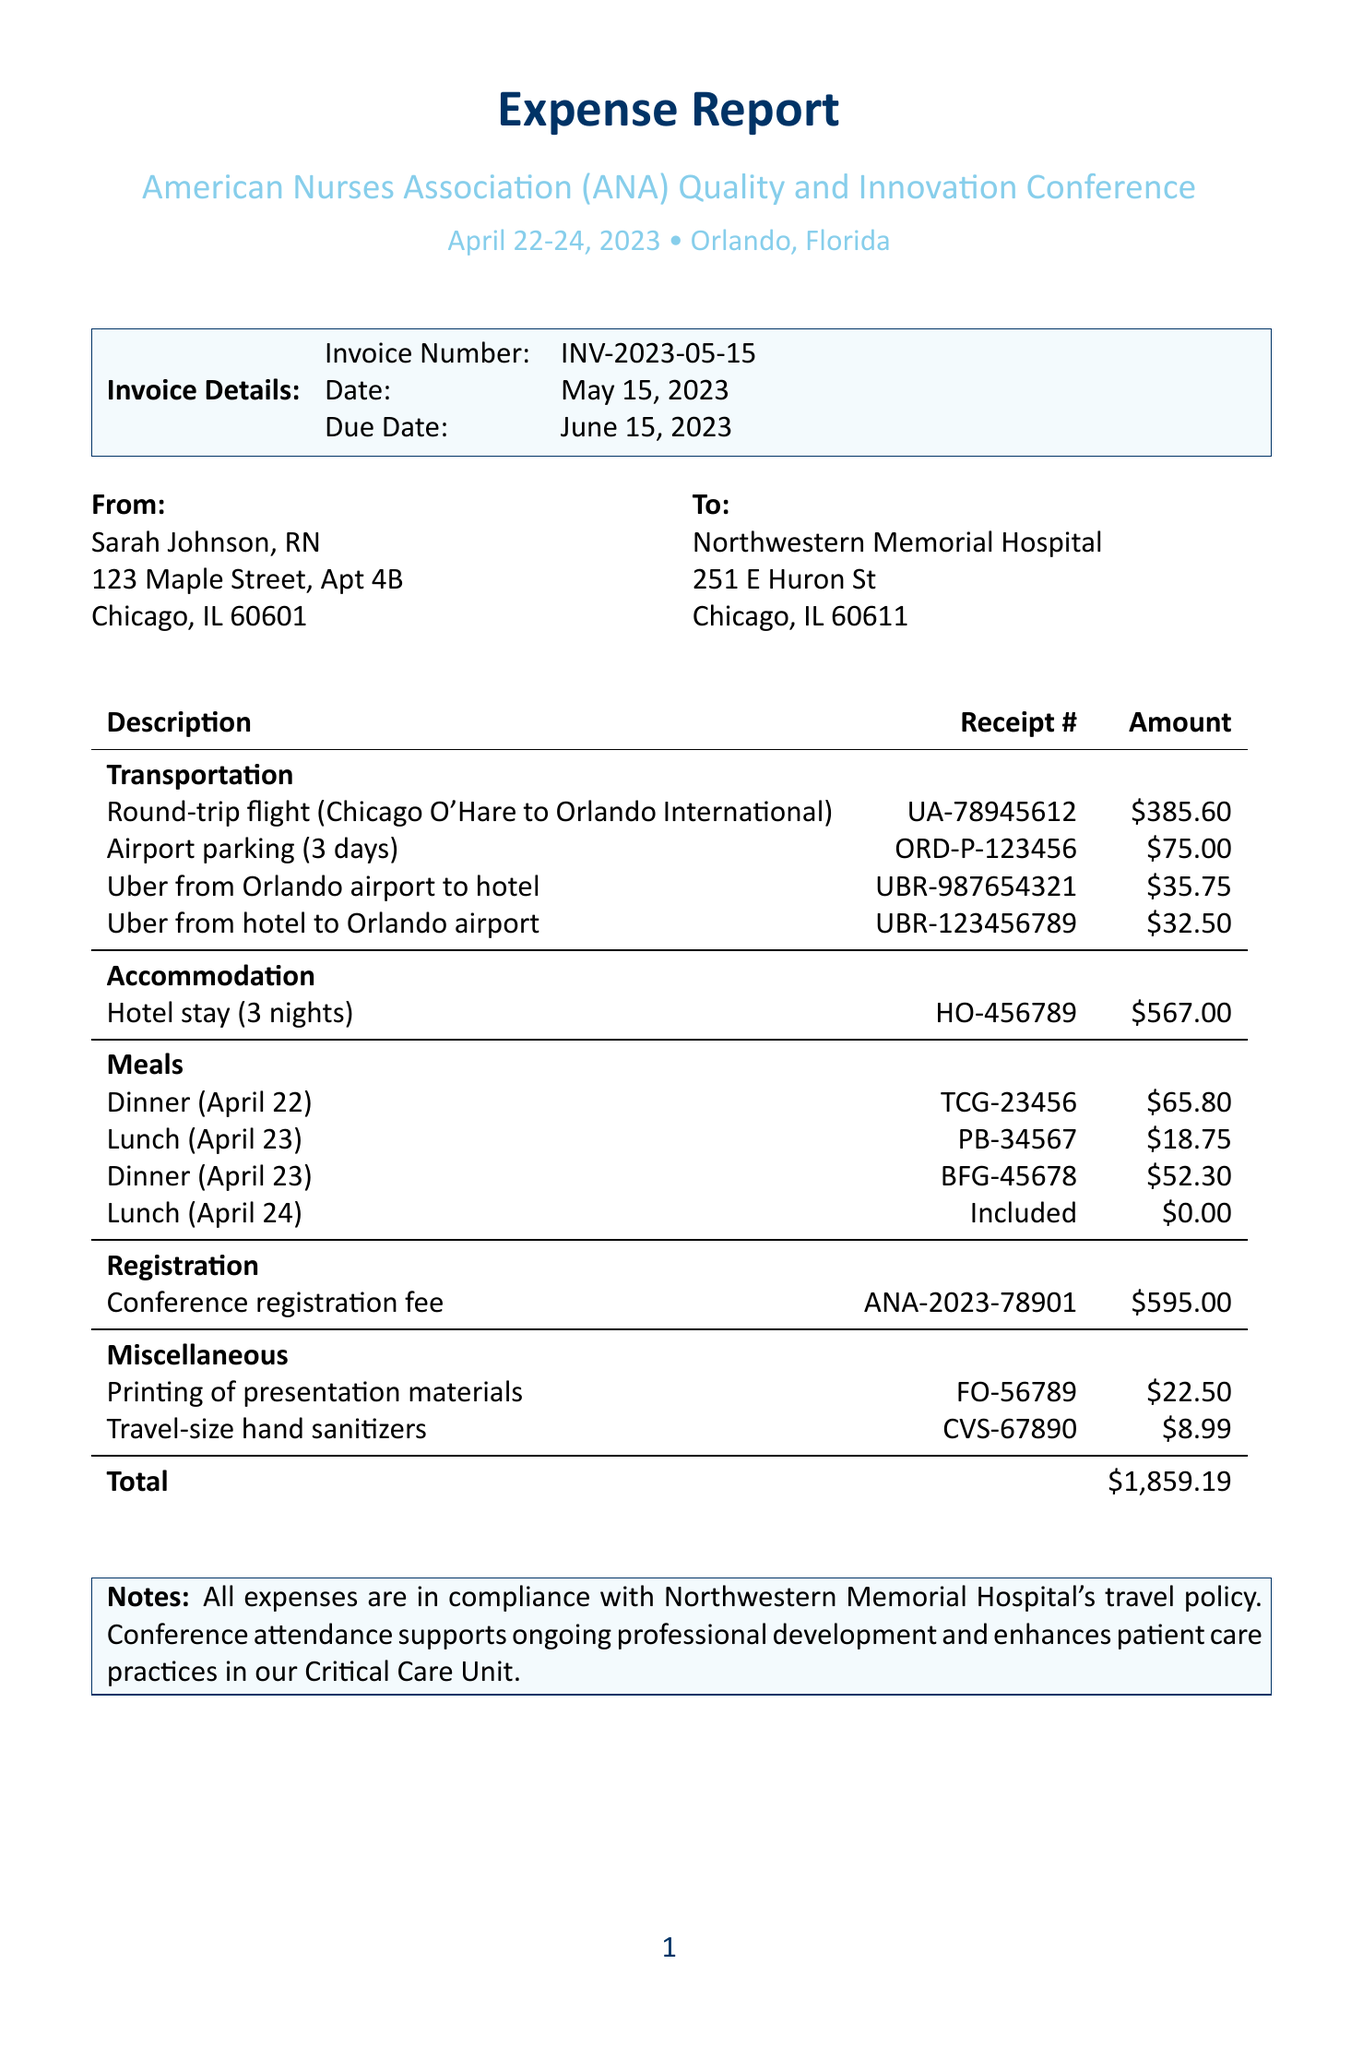What is the invoice number? The invoice number is a unique identifier for this expense report, found in the invoice details section.
Answer: INV-2023-05-15 Who is the payee? The payee is the person receiving the reimbursement for expenses, listed in the invoice details.
Answer: Sarah Johnson, RN What is the total amount of expenses? The total amount is the sum of all the listed expenses in the document, found at the end of the expense table.
Answer: $1,859.19 What category does the hotel stay fall under? The hotel stay is classified under the accommodation category in the expenses section.
Answer: Accommodation Which vendor provided the round-trip flight? The vendor is the company that provided the service, found under the transportation category in the expenses.
Answer: United Airlines What was the amount spent on meals? The amount spent on meals can be calculated by summing all the meal expenses listed under that category.
Answer: $137.85 What date did the conference take place? The date of the conference is mentioned in the conference details section.
Answer: April 22-24, 2023 What is included in the miscellaneous expenses? Miscellaneous expenses include small, non-categorized items, as listed in that section of the document.
Answer: Printing of presentation materials, Travel-size hand sanitizers for personal use What is the due date for this invoice? The due date indicates when the payment must be made, and it's listed clearly in the invoice details.
Answer: June 15, 2023 